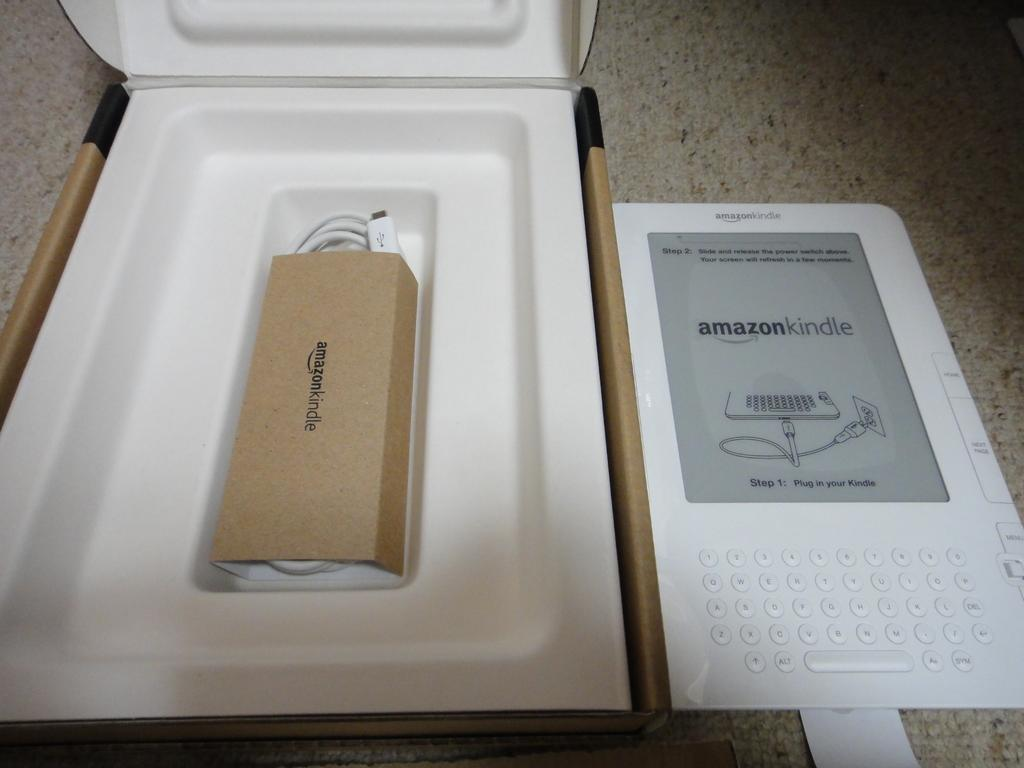<image>
Render a clear and concise summary of the photo. A white Amazon kindle sits to the right of its opened box. 